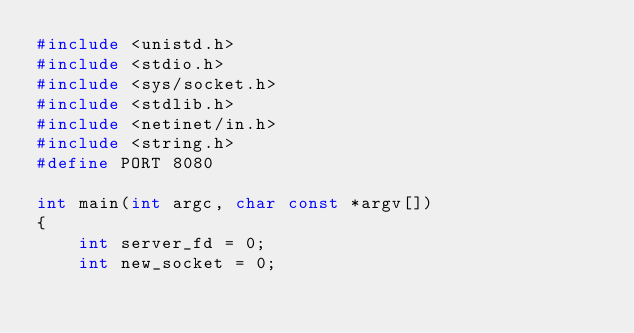Convert code to text. <code><loc_0><loc_0><loc_500><loc_500><_C++_>#include <unistd.h> 
#include <stdio.h> 
#include <sys/socket.h> 
#include <stdlib.h> 
#include <netinet/in.h> 
#include <string.h> 
#define PORT 8080

int main(int argc, char const *argv[]) 
{ 
	int server_fd = 0;
    int new_socket = 0; </code> 